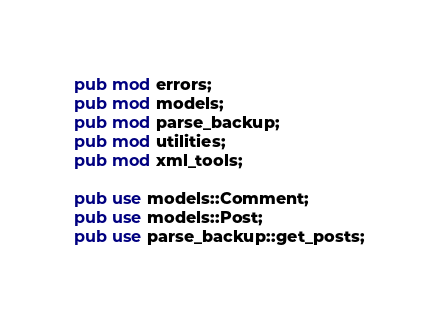Convert code to text. <code><loc_0><loc_0><loc_500><loc_500><_Rust_>pub mod errors;
pub mod models;
pub mod parse_backup;
pub mod utilities;
pub mod xml_tools;

pub use models::Comment;
pub use models::Post;
pub use parse_backup::get_posts;
</code> 